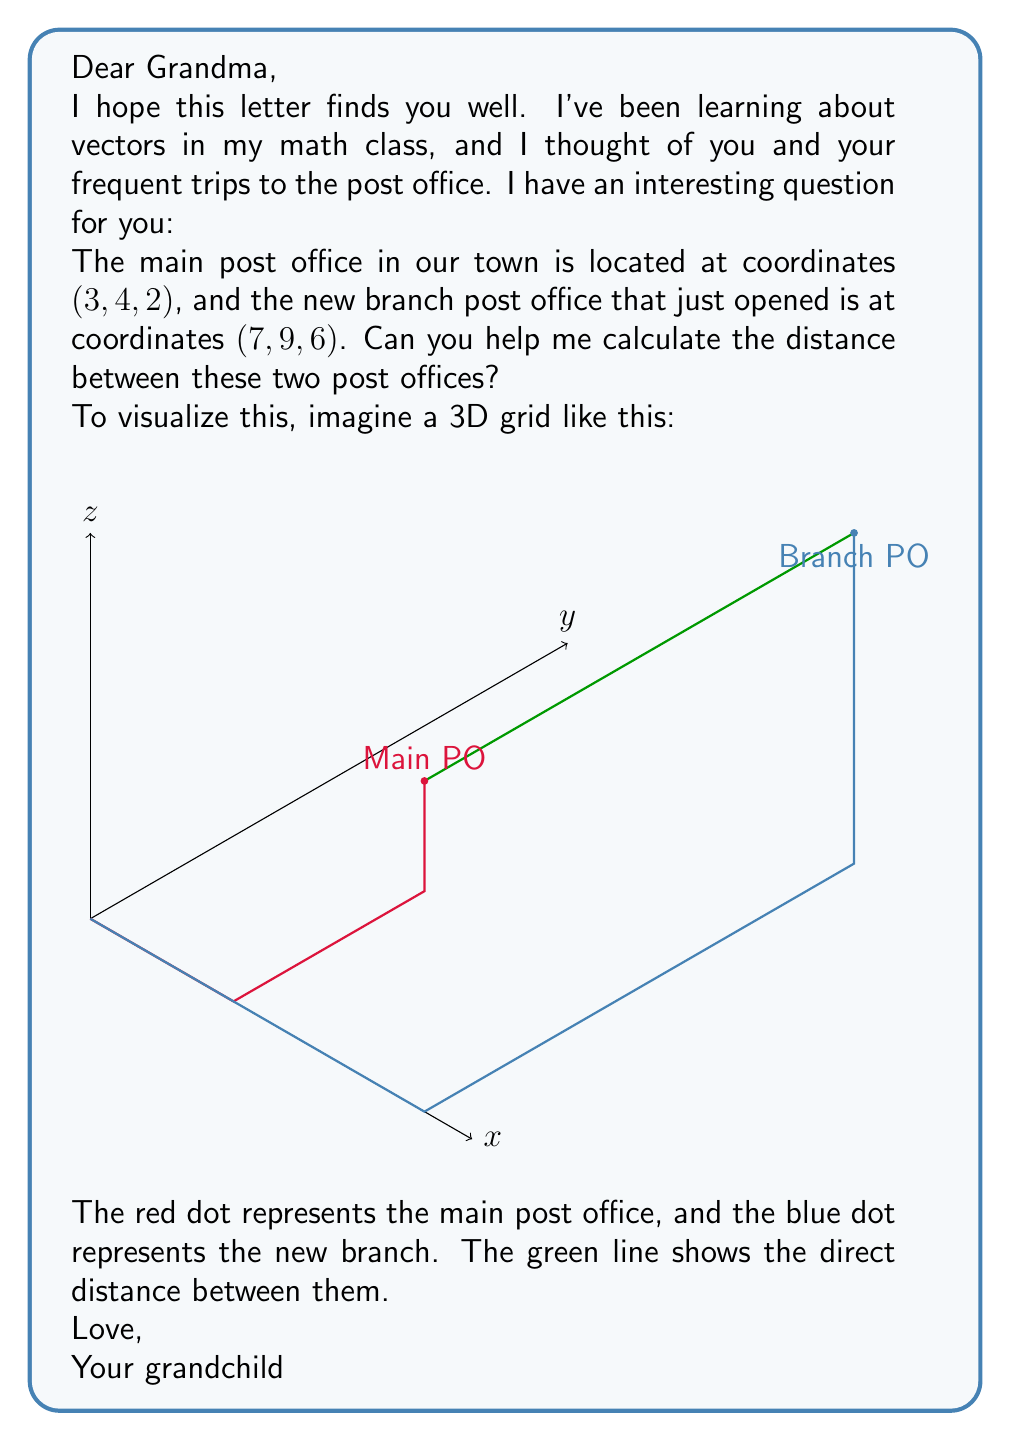Solve this math problem. To solve this problem, we can use the distance formula for 3D vectors. Here's how we can approach it step-by-step:

1) The distance formula between two points $(x_1, y_1, z_1)$ and $(x_2, y_2, z_2)$ in 3D space is:

   $$d = \sqrt{(x_2-x_1)^2 + (y_2-y_1)^2 + (z_2-z_1)^2}$$

2) In our case:
   - Main post office: $(x_1, y_1, z_1) = (3, 4, 2)$
   - Branch post office: $(x_2, y_2, z_2) = (7, 9, 6)$

3) Let's substitute these values into the formula:

   $$d = \sqrt{(7-3)^2 + (9-4)^2 + (6-2)^2}$$

4) Simplify the expressions inside the parentheses:

   $$d = \sqrt{4^2 + 5^2 + 4^2}$$

5) Calculate the squares:

   $$d = \sqrt{16 + 25 + 16}$$

6) Add the numbers under the square root:

   $$d = \sqrt{57}$$

7) This is our final answer, but we can simplify it further:

   $$d = 3\sqrt{19}$$

The distance between the two post offices is $3\sqrt{19}$ units.
Answer: $3\sqrt{19}$ units 